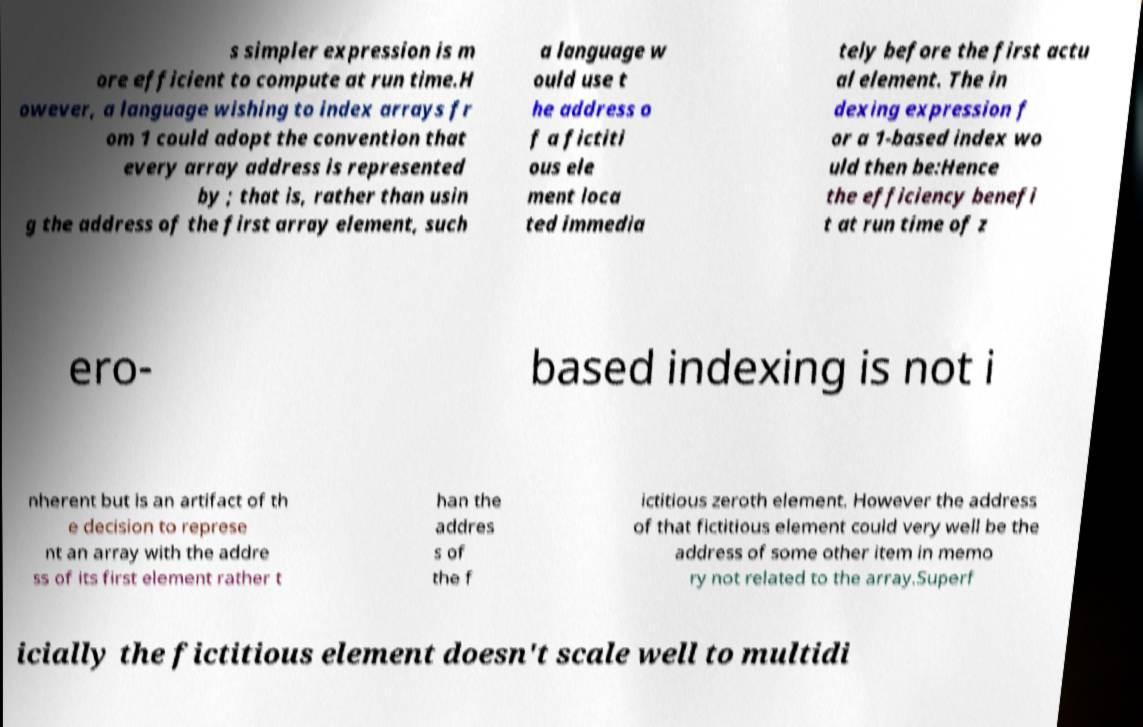There's text embedded in this image that I need extracted. Can you transcribe it verbatim? s simpler expression is m ore efficient to compute at run time.H owever, a language wishing to index arrays fr om 1 could adopt the convention that every array address is represented by ; that is, rather than usin g the address of the first array element, such a language w ould use t he address o f a fictiti ous ele ment loca ted immedia tely before the first actu al element. The in dexing expression f or a 1-based index wo uld then be:Hence the efficiency benefi t at run time of z ero- based indexing is not i nherent but is an artifact of th e decision to represe nt an array with the addre ss of its first element rather t han the addres s of the f ictitious zeroth element. However the address of that fictitious element could very well be the address of some other item in memo ry not related to the array.Superf icially the fictitious element doesn't scale well to multidi 